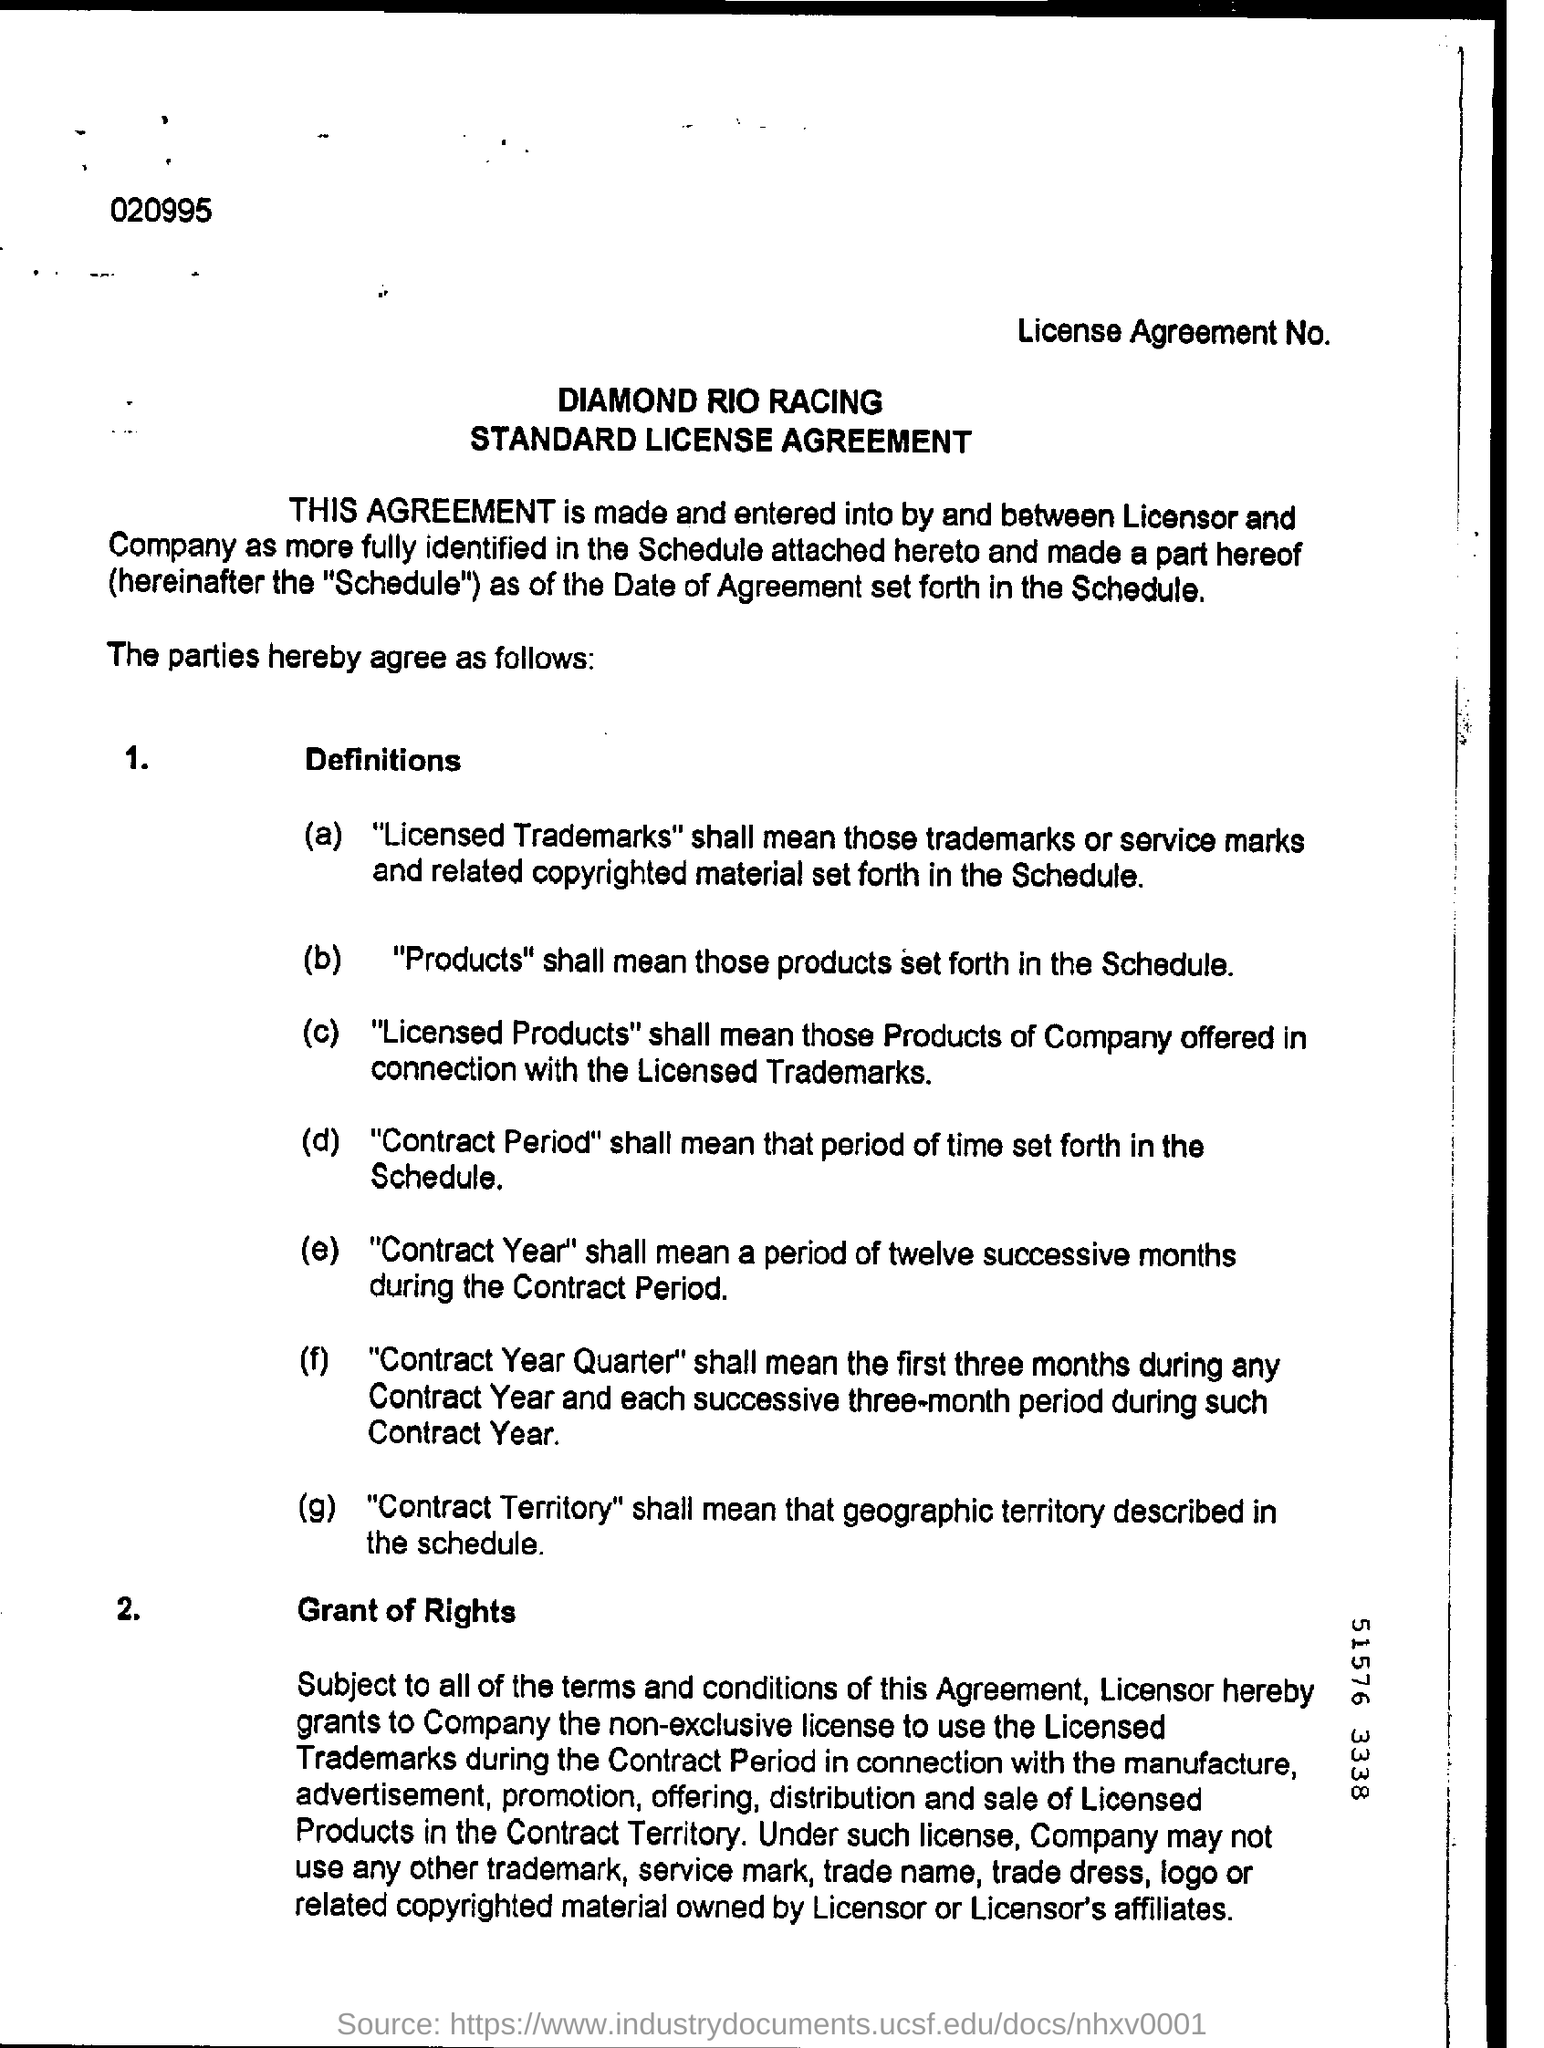Give some essential details in this illustration. The licensor and the company are the two parties that the license is made between. The second agreement is about granting rights. The number at the top left is 020995. 